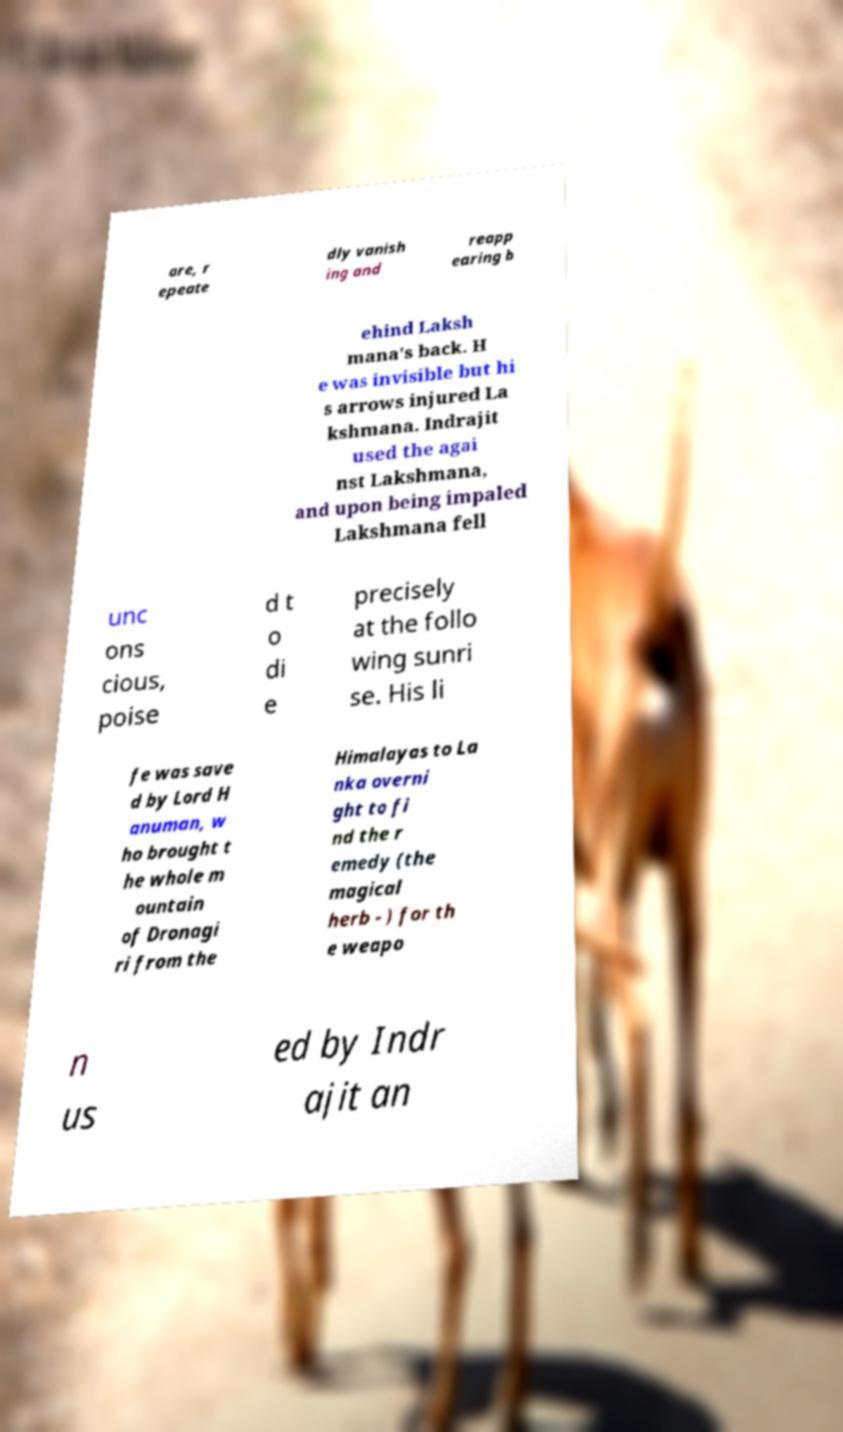Could you extract and type out the text from this image? are, r epeate dly vanish ing and reapp earing b ehind Laksh mana's back. H e was invisible but hi s arrows injured La kshmana. Indrajit used the agai nst Lakshmana, and upon being impaled Lakshmana fell unc ons cious, poise d t o di e precisely at the follo wing sunri se. His li fe was save d by Lord H anuman, w ho brought t he whole m ountain of Dronagi ri from the Himalayas to La nka overni ght to fi nd the r emedy (the magical herb - ) for th e weapo n us ed by Indr ajit an 